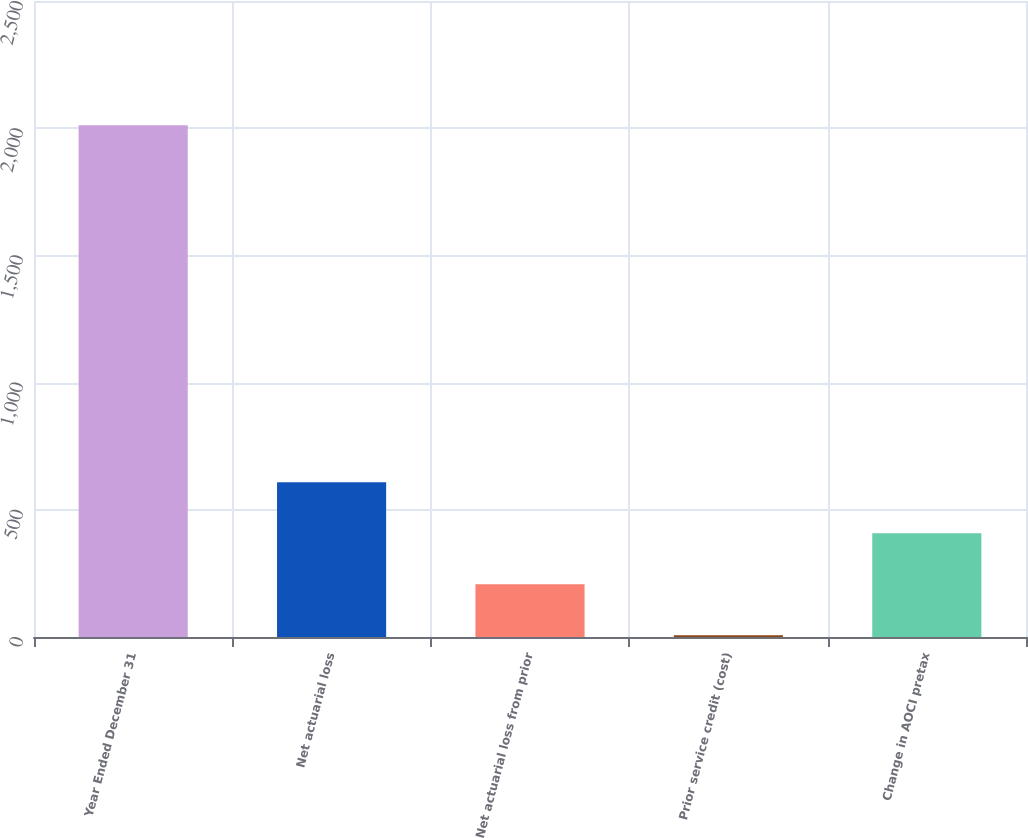<chart> <loc_0><loc_0><loc_500><loc_500><bar_chart><fcel>Year Ended December 31<fcel>Net actuarial loss<fcel>Net actuarial loss from prior<fcel>Prior service credit (cost)<fcel>Change in AOCI pretax<nl><fcel>2012<fcel>608.5<fcel>207.5<fcel>7<fcel>408<nl></chart> 